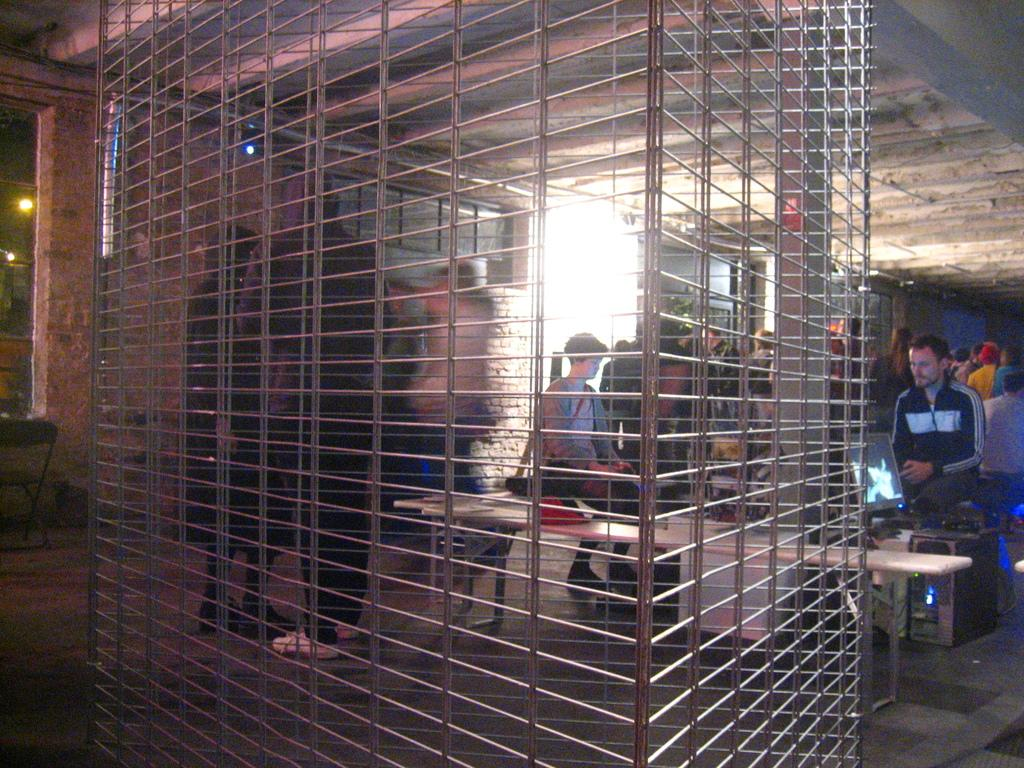What type of structure can be seen in the image? There is an iron railing in the image. What can be identified as a part of a larger system in the image? There is a CPU visible in the image. What are the people in the image doing? There are people sitting on tables in the image. What type of wall is present in the image? There is a brick wall in the image. How many women are visible in the image? There is no mention of women in the provided facts, so we cannot determine the number of women in the image. What is the cause of the CPU overheating in the image? There is no indication of the CPU overheating in the image, so we cannot determine the cause. 